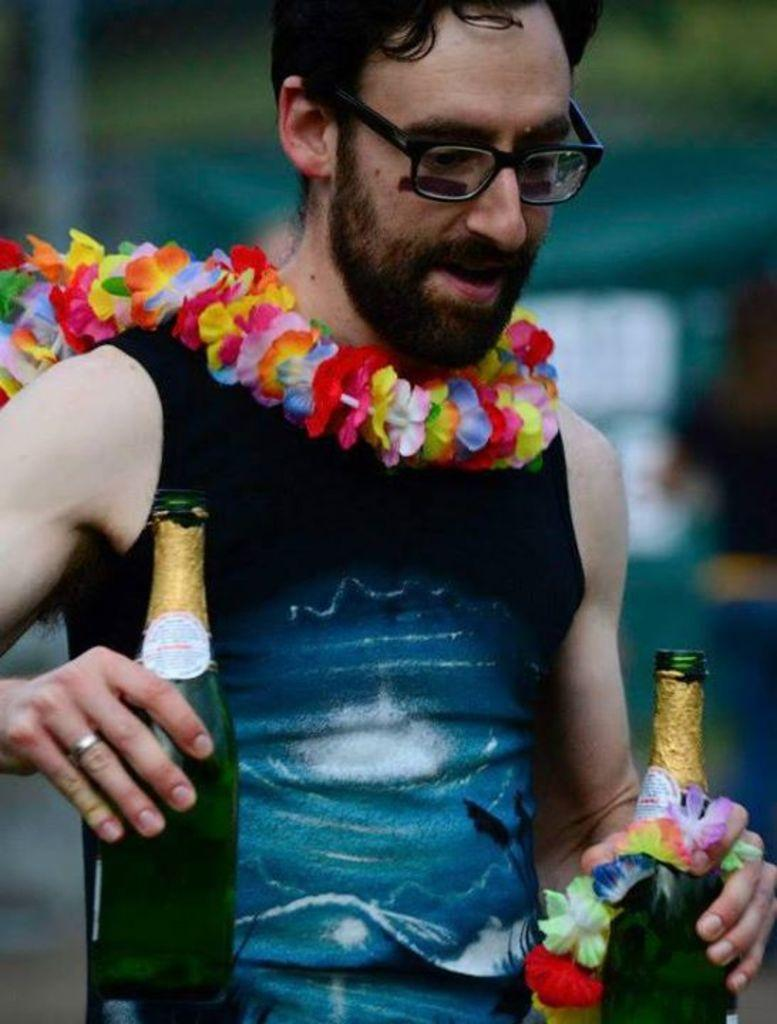What is the main subject of the picture? The main subject of the picture is a man. Can you describe the man's clothing? The man is wearing a blue t-shirt. Does the man have any accessories? Yes, the man is wearing spectacles. What is the man holding in his hands? The man is holding two bottles in his hands. Is there any decoration around the man's neck? Yes, there is a garland around the man's neck. What type of cake is being served on the land in the image? There is no cake or land present in the image; it features a man wearing a blue t-shirt, spectacles, and a garland, holding two bottles. How does the man apply the brake while holding the bottles in the image? There is no indication of a vehicle or braking mechanism in the image, as it only shows a man holding two bottles. 